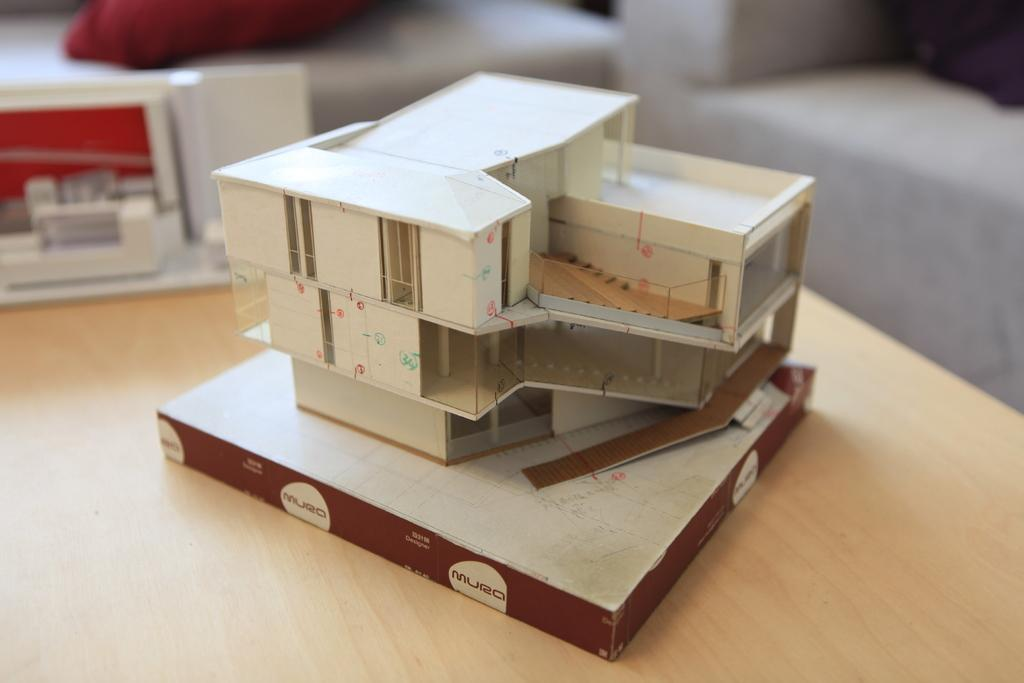What is the main object on the table in the image? There is a house plan on the table. What type of surface is the house plan placed on? The house plan is placed on a table. What brand of toothpaste is being used to clean the pigs in the image? There are no pigs or toothpaste present in the image; it only features a table with a house plan on it. 